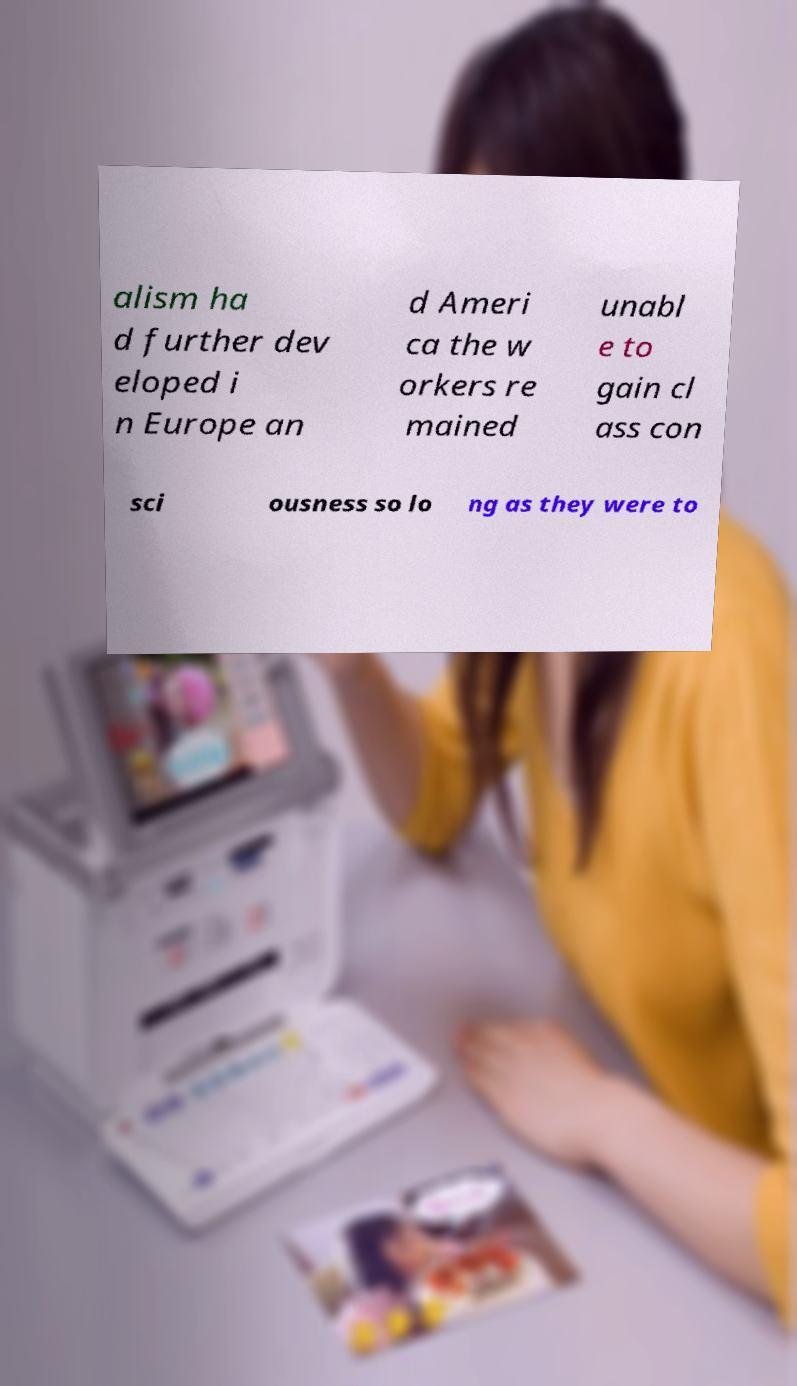Please read and relay the text visible in this image. What does it say? alism ha d further dev eloped i n Europe an d Ameri ca the w orkers re mained unabl e to gain cl ass con sci ousness so lo ng as they were to 